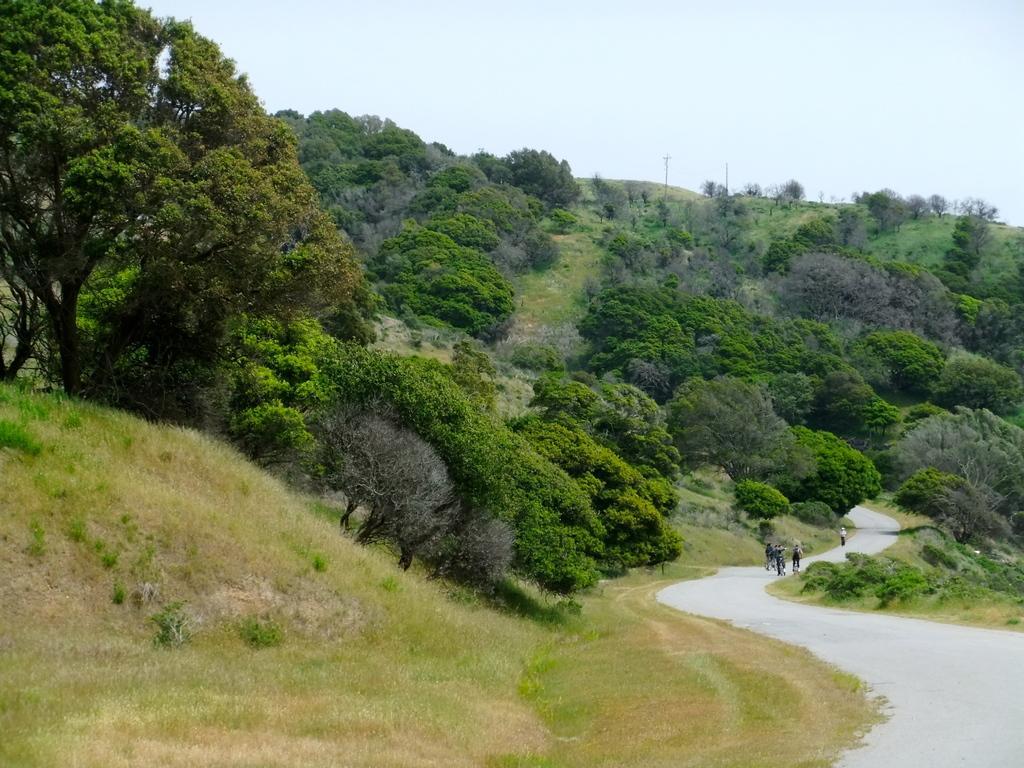In one or two sentences, can you explain what this image depicts? In this image I can see group of people and I can see few trees in green color, few poles and the sky is in blue and white color. 